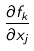<formula> <loc_0><loc_0><loc_500><loc_500>\frac { \partial f _ { k } } { \partial x _ { j } }</formula> 